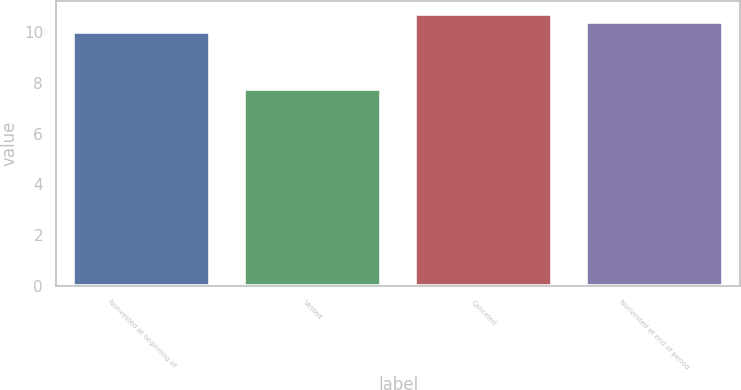<chart> <loc_0><loc_0><loc_500><loc_500><bar_chart><fcel>Nonvested at beginning of<fcel>Vested<fcel>Canceled<fcel>Nonvested at end of period<nl><fcel>9.99<fcel>7.77<fcel>10.7<fcel>10.39<nl></chart> 